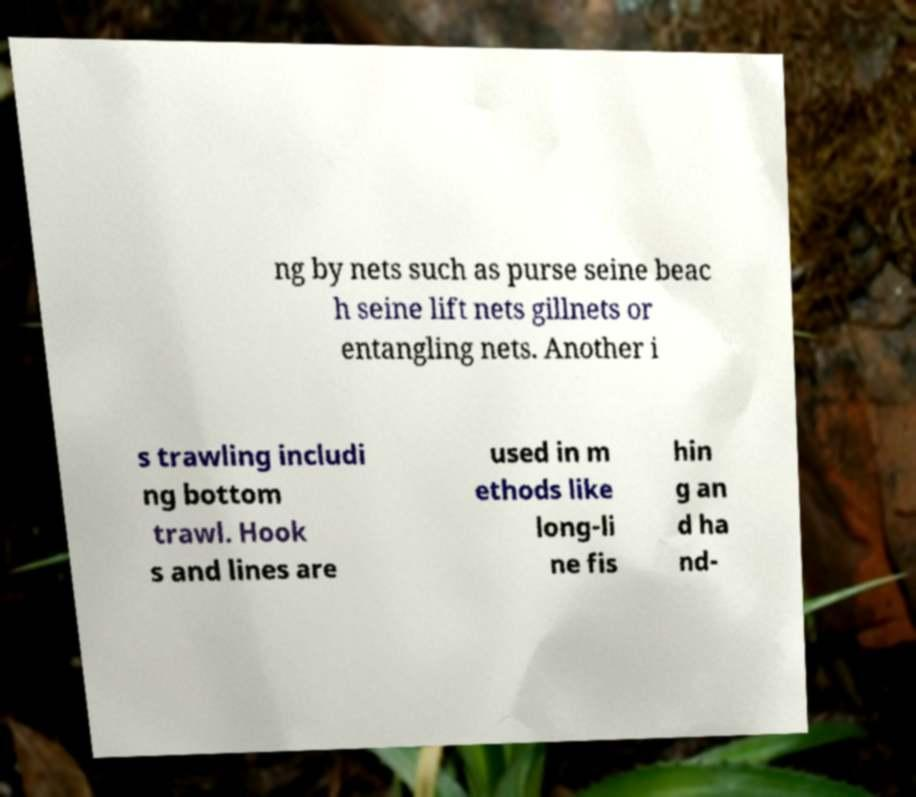What messages or text are displayed in this image? I need them in a readable, typed format. ng by nets such as purse seine beac h seine lift nets gillnets or entangling nets. Another i s trawling includi ng bottom trawl. Hook s and lines are used in m ethods like long-li ne fis hin g an d ha nd- 